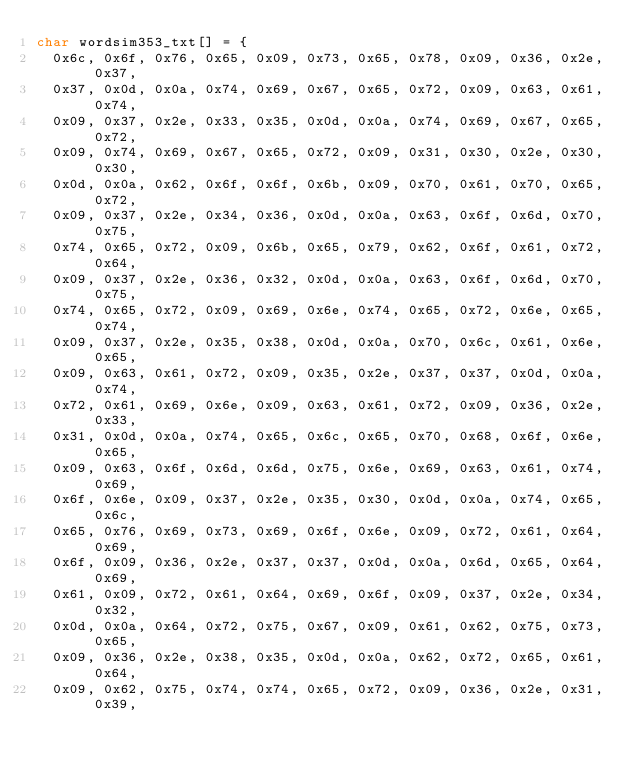<code> <loc_0><loc_0><loc_500><loc_500><_C_>char wordsim353_txt[] = {
  0x6c, 0x6f, 0x76, 0x65, 0x09, 0x73, 0x65, 0x78, 0x09, 0x36, 0x2e, 0x37,
  0x37, 0x0d, 0x0a, 0x74, 0x69, 0x67, 0x65, 0x72, 0x09, 0x63, 0x61, 0x74,
  0x09, 0x37, 0x2e, 0x33, 0x35, 0x0d, 0x0a, 0x74, 0x69, 0x67, 0x65, 0x72,
  0x09, 0x74, 0x69, 0x67, 0x65, 0x72, 0x09, 0x31, 0x30, 0x2e, 0x30, 0x30,
  0x0d, 0x0a, 0x62, 0x6f, 0x6f, 0x6b, 0x09, 0x70, 0x61, 0x70, 0x65, 0x72,
  0x09, 0x37, 0x2e, 0x34, 0x36, 0x0d, 0x0a, 0x63, 0x6f, 0x6d, 0x70, 0x75,
  0x74, 0x65, 0x72, 0x09, 0x6b, 0x65, 0x79, 0x62, 0x6f, 0x61, 0x72, 0x64,
  0x09, 0x37, 0x2e, 0x36, 0x32, 0x0d, 0x0a, 0x63, 0x6f, 0x6d, 0x70, 0x75,
  0x74, 0x65, 0x72, 0x09, 0x69, 0x6e, 0x74, 0x65, 0x72, 0x6e, 0x65, 0x74,
  0x09, 0x37, 0x2e, 0x35, 0x38, 0x0d, 0x0a, 0x70, 0x6c, 0x61, 0x6e, 0x65,
  0x09, 0x63, 0x61, 0x72, 0x09, 0x35, 0x2e, 0x37, 0x37, 0x0d, 0x0a, 0x74,
  0x72, 0x61, 0x69, 0x6e, 0x09, 0x63, 0x61, 0x72, 0x09, 0x36, 0x2e, 0x33,
  0x31, 0x0d, 0x0a, 0x74, 0x65, 0x6c, 0x65, 0x70, 0x68, 0x6f, 0x6e, 0x65,
  0x09, 0x63, 0x6f, 0x6d, 0x6d, 0x75, 0x6e, 0x69, 0x63, 0x61, 0x74, 0x69,
  0x6f, 0x6e, 0x09, 0x37, 0x2e, 0x35, 0x30, 0x0d, 0x0a, 0x74, 0x65, 0x6c,
  0x65, 0x76, 0x69, 0x73, 0x69, 0x6f, 0x6e, 0x09, 0x72, 0x61, 0x64, 0x69,
  0x6f, 0x09, 0x36, 0x2e, 0x37, 0x37, 0x0d, 0x0a, 0x6d, 0x65, 0x64, 0x69,
  0x61, 0x09, 0x72, 0x61, 0x64, 0x69, 0x6f, 0x09, 0x37, 0x2e, 0x34, 0x32,
  0x0d, 0x0a, 0x64, 0x72, 0x75, 0x67, 0x09, 0x61, 0x62, 0x75, 0x73, 0x65,
  0x09, 0x36, 0x2e, 0x38, 0x35, 0x0d, 0x0a, 0x62, 0x72, 0x65, 0x61, 0x64,
  0x09, 0x62, 0x75, 0x74, 0x74, 0x65, 0x72, 0x09, 0x36, 0x2e, 0x31, 0x39,</code> 